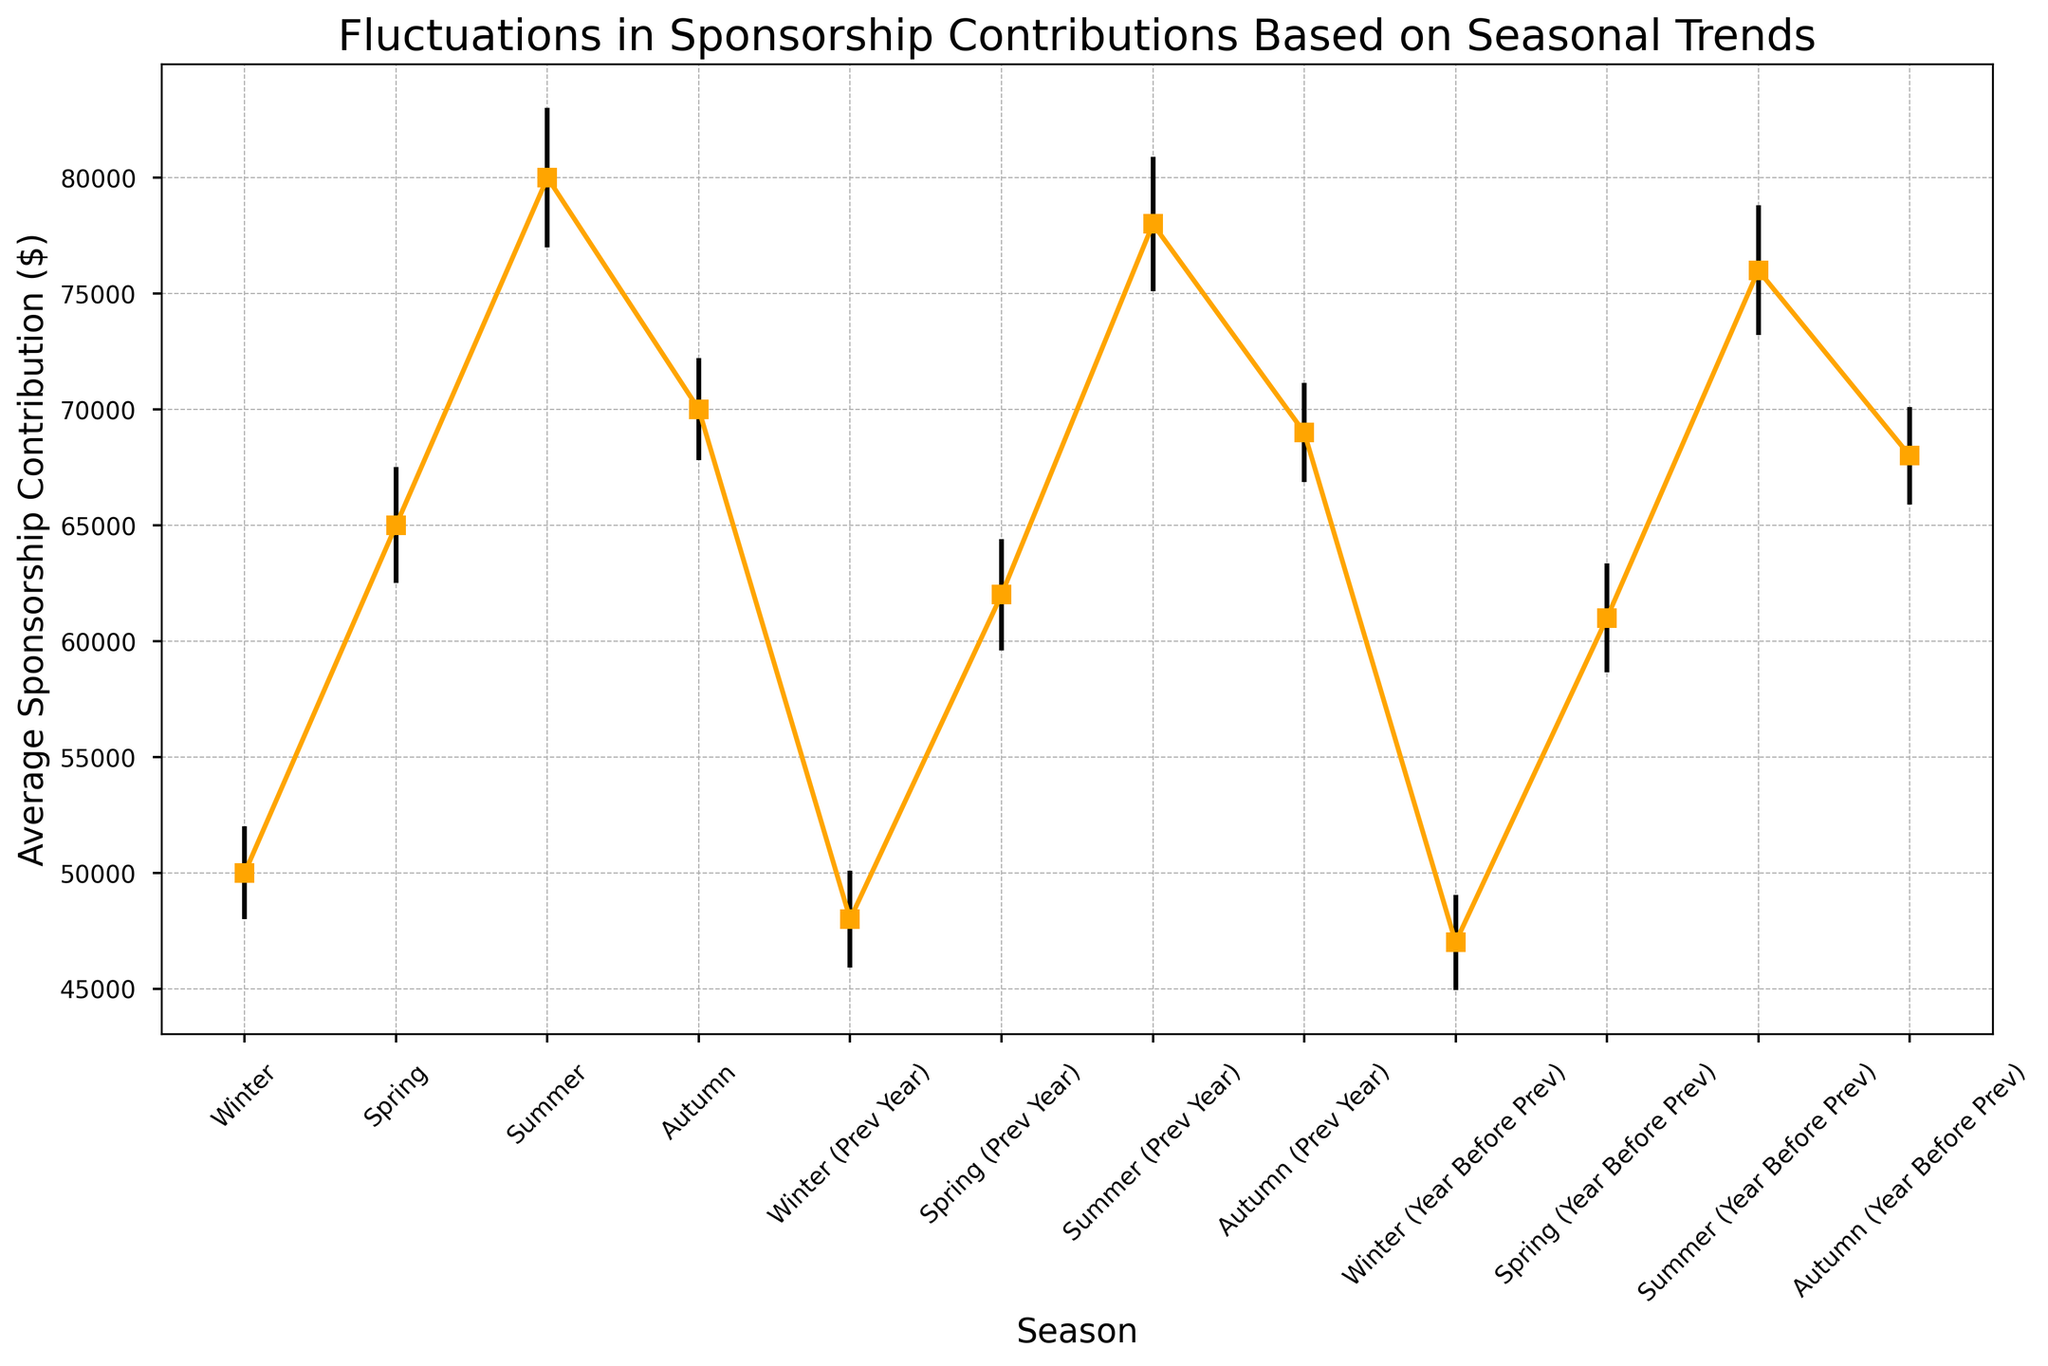Which season has the highest average sponsorship contribution? Look at the data points and identify the season with the highest vertical position on the plot. The tallest error bar belongs to "Summer" with an average sponsorship contribution of $80,000.
Answer: Summer How does the average sponsorship in Summer compare to Winter? Find the data points for Summer and Winter and compare their average sponsorship contributions. Summer has $80,000 and Winter has $50,000, so Summer is higher by $30,000.
Answer: Summer is higher by $30,000 What is the average sponsorship contribution for Autumn over the three years shown? Calculate the average of the values for Autumn: (70,000 + 69,000 + 68,000) / 3 = 69,000.
Answer: $69,000 Which year had the highest contribution in Spring? Observe the data points for Spring across different years and determine which year has the highest value. The highest value for Spring is $65,000 in the current year.
Answer: Current year What is the difference in average sponsorship contributions between the current Spring and Winter? Subtract the average contribution of Winter from Spring for the current year: 65,000 - 50,000 = 15,000.
Answer: $15,000 Rank the seasons from highest to lowest based on their average sponsorship contributions for the most recent year. Look at the average contribution values for each season in the most recent year and sort them: Summer ($80,000), Autumn ($70,000), Spring ($65,000), Winter ($50,000).
Answer: Summer > Autumn > Spring > Winter What is the range of average sponsorship contributions in Autumn for the three years? Find the minimum and maximum values for Autumn and subtract the minimum from the maximum: 70,000 - 68,000 = 2,000.
Answer: $2,000 How consistent are the summer sponsorship contributions over the years? Evaluate the error bars for Summer contributions to see the variability. Summer has quite consistent values: 80,000, 78,000, and 76,000 with relatively similar error margins.
Answer: Quite consistent How do the contributions in Winter compare between the previous year and the year before that? Compare the average contributions for Winter in both years: 48,000 (previous year) vs. 47,000 (year before that). The difference is 1,000.
Answer: Previous year is 1,000 higher Is the standard error for Autumn smaller or larger than that of Winter in the most recent year? Compare the lengths of the error bars for Autumn and Winter. Autumn has an error of 2,200, and Winter has 2,000.
Answer: Larger 